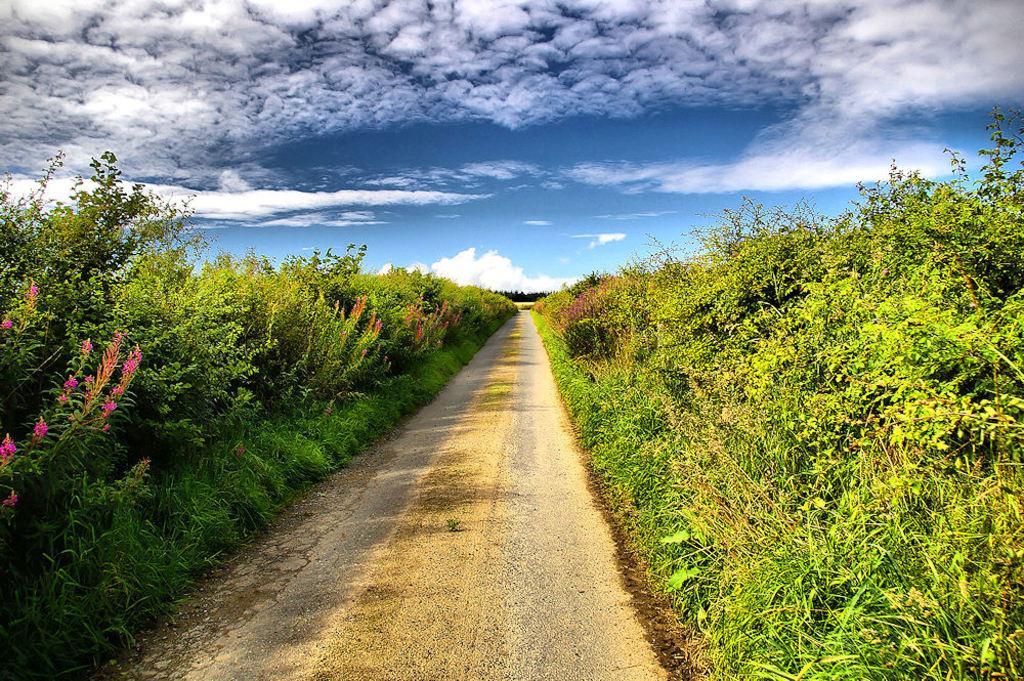Describe this image in one or two sentences. In this picture we can see a pathway. On the left and right side of the pathway there are trees. Behind the trees there is the cloudy sky. 